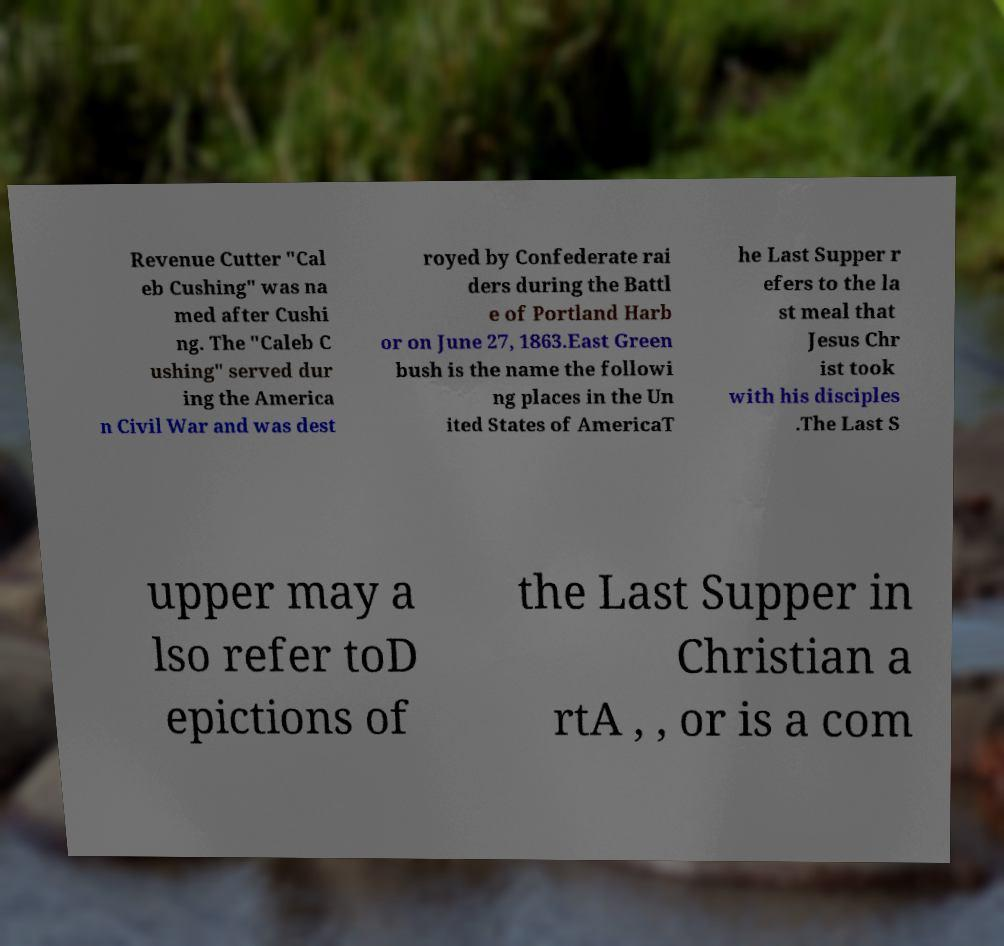I need the written content from this picture converted into text. Can you do that? Revenue Cutter "Cal eb Cushing" was na med after Cushi ng. The "Caleb C ushing" served dur ing the America n Civil War and was dest royed by Confederate rai ders during the Battl e of Portland Harb or on June 27, 1863.East Green bush is the name the followi ng places in the Un ited States of AmericaT he Last Supper r efers to the la st meal that Jesus Chr ist took with his disciples .The Last S upper may a lso refer toD epictions of the Last Supper in Christian a rtA , , or is a com 